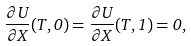Convert formula to latex. <formula><loc_0><loc_0><loc_500><loc_500>\frac { \partial U } { \partial X } ( T , 0 ) = \frac { \partial U } { \partial X } ( T , 1 ) = 0 ,</formula> 